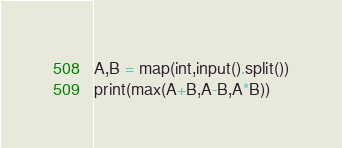<code> <loc_0><loc_0><loc_500><loc_500><_Python_>A,B = map(int,input().split())
print(max(A+B,A-B,A*B))</code> 